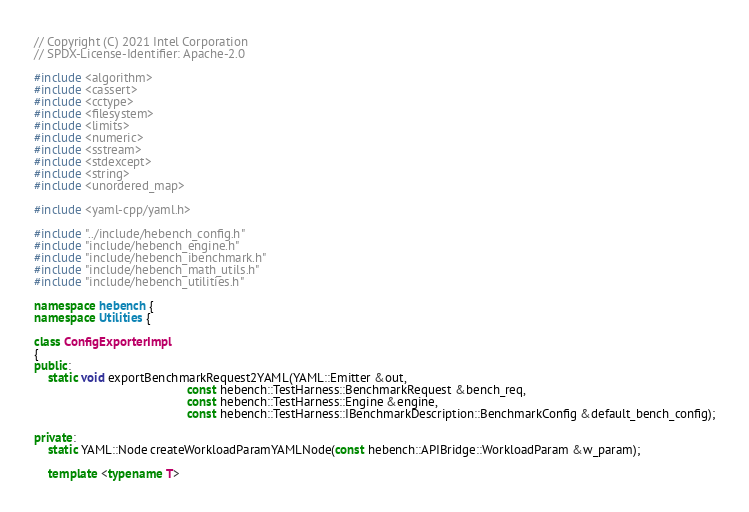Convert code to text. <code><loc_0><loc_0><loc_500><loc_500><_C++_>
// Copyright (C) 2021 Intel Corporation
// SPDX-License-Identifier: Apache-2.0

#include <algorithm>
#include <cassert>
#include <cctype>
#include <filesystem>
#include <limits>
#include <numeric>
#include <sstream>
#include <stdexcept>
#include <string>
#include <unordered_map>

#include <yaml-cpp/yaml.h>

#include "../include/hebench_config.h"
#include "include/hebench_engine.h"
#include "include/hebench_ibenchmark.h"
#include "include/hebench_math_utils.h"
#include "include/hebench_utilities.h"

namespace hebench {
namespace Utilities {

class ConfigExporterImpl
{
public:
    static void exportBenchmarkRequest2YAML(YAML::Emitter &out,
                                            const hebench::TestHarness::BenchmarkRequest &bench_req,
                                            const hebench::TestHarness::Engine &engine,
                                            const hebench::TestHarness::IBenchmarkDescription::BenchmarkConfig &default_bench_config);

private:
    static YAML::Node createWorkloadParamYAMLNode(const hebench::APIBridge::WorkloadParam &w_param);

    template <typename T></code> 